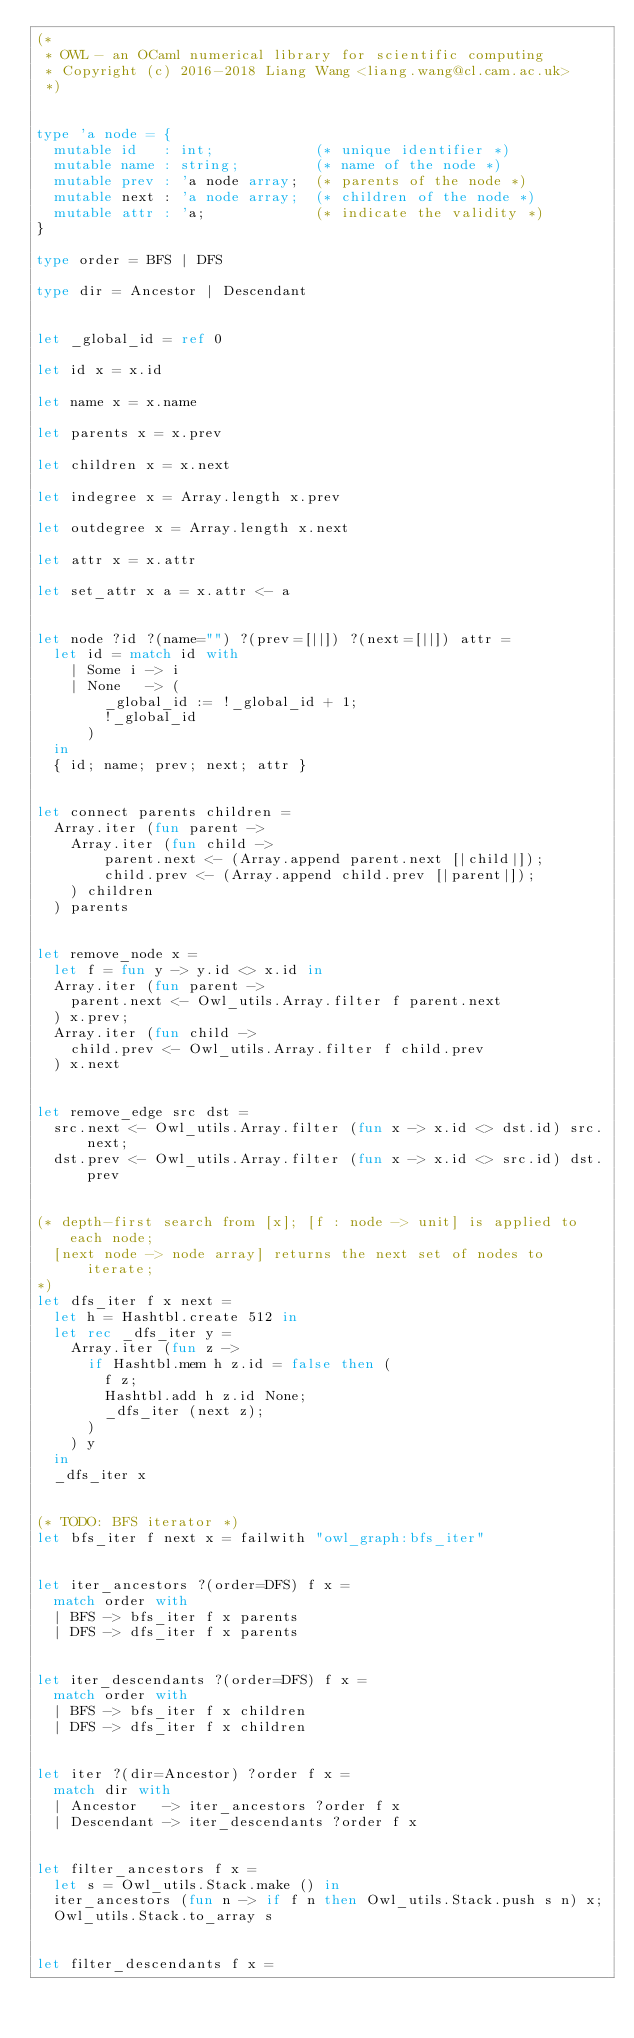<code> <loc_0><loc_0><loc_500><loc_500><_OCaml_>(*
 * OWL - an OCaml numerical library for scientific computing
 * Copyright (c) 2016-2018 Liang Wang <liang.wang@cl.cam.ac.uk>
 *)


type 'a node = {
  mutable id   : int;            (* unique identifier *)
  mutable name : string;         (* name of the node *)
  mutable prev : 'a node array;  (* parents of the node *)
  mutable next : 'a node array;  (* children of the node *)
  mutable attr : 'a;             (* indicate the validity *)
}

type order = BFS | DFS

type dir = Ancestor | Descendant


let _global_id = ref 0

let id x = x.id

let name x = x.name

let parents x = x.prev

let children x = x.next

let indegree x = Array.length x.prev

let outdegree x = Array.length x.next

let attr x = x.attr

let set_attr x a = x.attr <- a


let node ?id ?(name="") ?(prev=[||]) ?(next=[||]) attr =
  let id = match id with
    | Some i -> i
    | None   -> (
        _global_id := !_global_id + 1;
        !_global_id
      )
  in
  { id; name; prev; next; attr }


let connect parents children =
  Array.iter (fun parent ->
    Array.iter (fun child ->
        parent.next <- (Array.append parent.next [|child|]);
        child.prev <- (Array.append child.prev [|parent|]);
    ) children
  ) parents


let remove_node x =
  let f = fun y -> y.id <> x.id in
  Array.iter (fun parent ->
    parent.next <- Owl_utils.Array.filter f parent.next
  ) x.prev;
  Array.iter (fun child ->
    child.prev <- Owl_utils.Array.filter f child.prev
  ) x.next


let remove_edge src dst =
  src.next <- Owl_utils.Array.filter (fun x -> x.id <> dst.id) src.next;
  dst.prev <- Owl_utils.Array.filter (fun x -> x.id <> src.id) dst.prev


(* depth-first search from [x]; [f : node -> unit] is applied to each node;
  [next node -> node array] returns the next set of nodes to iterate;
*)
let dfs_iter f x next =
  let h = Hashtbl.create 512 in
  let rec _dfs_iter y =
    Array.iter (fun z ->
      if Hashtbl.mem h z.id = false then (
        f z;
        Hashtbl.add h z.id None;
        _dfs_iter (next z);
      )
    ) y
  in
  _dfs_iter x


(* TODO: BFS iterator *)
let bfs_iter f next x = failwith "owl_graph:bfs_iter"


let iter_ancestors ?(order=DFS) f x =
  match order with
  | BFS -> bfs_iter f x parents
  | DFS -> dfs_iter f x parents


let iter_descendants ?(order=DFS) f x =
  match order with
  | BFS -> bfs_iter f x children
  | DFS -> dfs_iter f x children


let iter ?(dir=Ancestor) ?order f x =
  match dir with
  | Ancestor   -> iter_ancestors ?order f x
  | Descendant -> iter_descendants ?order f x


let filter_ancestors f x =
  let s = Owl_utils.Stack.make () in
  iter_ancestors (fun n -> if f n then Owl_utils.Stack.push s n) x;
  Owl_utils.Stack.to_array s


let filter_descendants f x =</code> 